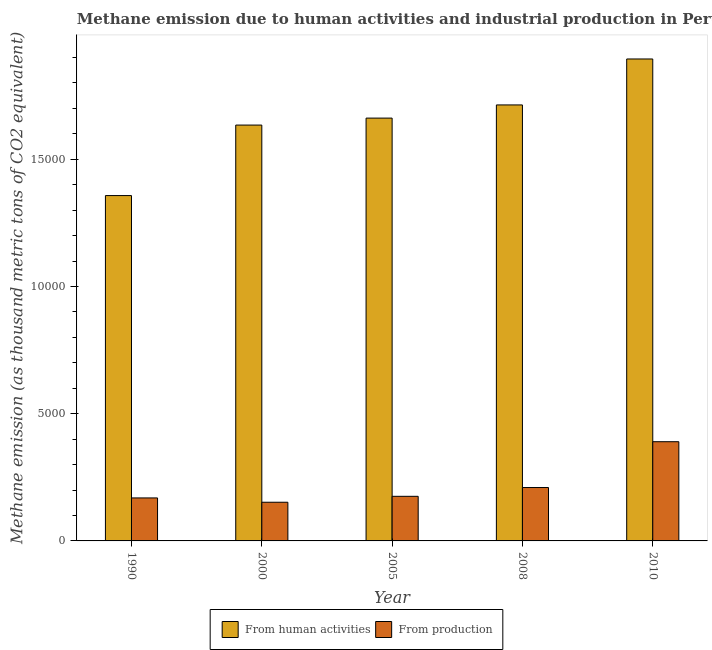How many different coloured bars are there?
Your answer should be compact. 2. How many groups of bars are there?
Offer a very short reply. 5. How many bars are there on the 2nd tick from the left?
Your response must be concise. 2. How many bars are there on the 3rd tick from the right?
Provide a short and direct response. 2. What is the label of the 1st group of bars from the left?
Offer a very short reply. 1990. In how many cases, is the number of bars for a given year not equal to the number of legend labels?
Your answer should be compact. 0. What is the amount of emissions from human activities in 2008?
Your answer should be very brief. 1.71e+04. Across all years, what is the maximum amount of emissions generated from industries?
Offer a terse response. 3899.3. Across all years, what is the minimum amount of emissions from human activities?
Your response must be concise. 1.36e+04. In which year was the amount of emissions from human activities maximum?
Offer a terse response. 2010. What is the total amount of emissions from human activities in the graph?
Ensure brevity in your answer.  8.26e+04. What is the difference between the amount of emissions generated from industries in 2000 and that in 2008?
Offer a terse response. -578.2. What is the difference between the amount of emissions generated from industries in 1990 and the amount of emissions from human activities in 2008?
Give a very brief answer. -408.9. What is the average amount of emissions from human activities per year?
Provide a short and direct response. 1.65e+04. In the year 1990, what is the difference between the amount of emissions from human activities and amount of emissions generated from industries?
Give a very brief answer. 0. In how many years, is the amount of emissions generated from industries greater than 14000 thousand metric tons?
Ensure brevity in your answer.  0. What is the ratio of the amount of emissions generated from industries in 1990 to that in 2005?
Offer a terse response. 0.96. What is the difference between the highest and the second highest amount of emissions generated from industries?
Offer a very short reply. 1800.6. What is the difference between the highest and the lowest amount of emissions from human activities?
Provide a short and direct response. 5369.2. In how many years, is the amount of emissions generated from industries greater than the average amount of emissions generated from industries taken over all years?
Your response must be concise. 1. What does the 2nd bar from the left in 2010 represents?
Provide a succinct answer. From production. What does the 2nd bar from the right in 2010 represents?
Provide a short and direct response. From human activities. How many years are there in the graph?
Your answer should be compact. 5. Where does the legend appear in the graph?
Give a very brief answer. Bottom center. What is the title of the graph?
Ensure brevity in your answer.  Methane emission due to human activities and industrial production in Peru. Does "Pregnant women" appear as one of the legend labels in the graph?
Your answer should be compact. No. What is the label or title of the X-axis?
Your answer should be very brief. Year. What is the label or title of the Y-axis?
Your response must be concise. Methane emission (as thousand metric tons of CO2 equivalent). What is the Methane emission (as thousand metric tons of CO2 equivalent) in From human activities in 1990?
Provide a short and direct response. 1.36e+04. What is the Methane emission (as thousand metric tons of CO2 equivalent) of From production in 1990?
Provide a succinct answer. 1689.8. What is the Methane emission (as thousand metric tons of CO2 equivalent) of From human activities in 2000?
Your response must be concise. 1.63e+04. What is the Methane emission (as thousand metric tons of CO2 equivalent) of From production in 2000?
Ensure brevity in your answer.  1520.5. What is the Methane emission (as thousand metric tons of CO2 equivalent) of From human activities in 2005?
Offer a very short reply. 1.66e+04. What is the Methane emission (as thousand metric tons of CO2 equivalent) of From production in 2005?
Your response must be concise. 1753.1. What is the Methane emission (as thousand metric tons of CO2 equivalent) in From human activities in 2008?
Offer a terse response. 1.71e+04. What is the Methane emission (as thousand metric tons of CO2 equivalent) in From production in 2008?
Ensure brevity in your answer.  2098.7. What is the Methane emission (as thousand metric tons of CO2 equivalent) of From human activities in 2010?
Provide a short and direct response. 1.89e+04. What is the Methane emission (as thousand metric tons of CO2 equivalent) in From production in 2010?
Your answer should be compact. 3899.3. Across all years, what is the maximum Methane emission (as thousand metric tons of CO2 equivalent) of From human activities?
Your response must be concise. 1.89e+04. Across all years, what is the maximum Methane emission (as thousand metric tons of CO2 equivalent) in From production?
Make the answer very short. 3899.3. Across all years, what is the minimum Methane emission (as thousand metric tons of CO2 equivalent) in From human activities?
Give a very brief answer. 1.36e+04. Across all years, what is the minimum Methane emission (as thousand metric tons of CO2 equivalent) in From production?
Give a very brief answer. 1520.5. What is the total Methane emission (as thousand metric tons of CO2 equivalent) in From human activities in the graph?
Offer a very short reply. 8.26e+04. What is the total Methane emission (as thousand metric tons of CO2 equivalent) of From production in the graph?
Your response must be concise. 1.10e+04. What is the difference between the Methane emission (as thousand metric tons of CO2 equivalent) of From human activities in 1990 and that in 2000?
Provide a short and direct response. -2771.4. What is the difference between the Methane emission (as thousand metric tons of CO2 equivalent) in From production in 1990 and that in 2000?
Provide a succinct answer. 169.3. What is the difference between the Methane emission (as thousand metric tons of CO2 equivalent) in From human activities in 1990 and that in 2005?
Offer a terse response. -3045.3. What is the difference between the Methane emission (as thousand metric tons of CO2 equivalent) of From production in 1990 and that in 2005?
Provide a short and direct response. -63.3. What is the difference between the Methane emission (as thousand metric tons of CO2 equivalent) of From human activities in 1990 and that in 2008?
Your answer should be very brief. -3562.7. What is the difference between the Methane emission (as thousand metric tons of CO2 equivalent) of From production in 1990 and that in 2008?
Ensure brevity in your answer.  -408.9. What is the difference between the Methane emission (as thousand metric tons of CO2 equivalent) in From human activities in 1990 and that in 2010?
Make the answer very short. -5369.2. What is the difference between the Methane emission (as thousand metric tons of CO2 equivalent) of From production in 1990 and that in 2010?
Give a very brief answer. -2209.5. What is the difference between the Methane emission (as thousand metric tons of CO2 equivalent) in From human activities in 2000 and that in 2005?
Offer a terse response. -273.9. What is the difference between the Methane emission (as thousand metric tons of CO2 equivalent) in From production in 2000 and that in 2005?
Provide a succinct answer. -232.6. What is the difference between the Methane emission (as thousand metric tons of CO2 equivalent) in From human activities in 2000 and that in 2008?
Keep it short and to the point. -791.3. What is the difference between the Methane emission (as thousand metric tons of CO2 equivalent) in From production in 2000 and that in 2008?
Keep it short and to the point. -578.2. What is the difference between the Methane emission (as thousand metric tons of CO2 equivalent) in From human activities in 2000 and that in 2010?
Ensure brevity in your answer.  -2597.8. What is the difference between the Methane emission (as thousand metric tons of CO2 equivalent) of From production in 2000 and that in 2010?
Offer a terse response. -2378.8. What is the difference between the Methane emission (as thousand metric tons of CO2 equivalent) in From human activities in 2005 and that in 2008?
Keep it short and to the point. -517.4. What is the difference between the Methane emission (as thousand metric tons of CO2 equivalent) of From production in 2005 and that in 2008?
Offer a terse response. -345.6. What is the difference between the Methane emission (as thousand metric tons of CO2 equivalent) of From human activities in 2005 and that in 2010?
Provide a succinct answer. -2323.9. What is the difference between the Methane emission (as thousand metric tons of CO2 equivalent) in From production in 2005 and that in 2010?
Make the answer very short. -2146.2. What is the difference between the Methane emission (as thousand metric tons of CO2 equivalent) in From human activities in 2008 and that in 2010?
Keep it short and to the point. -1806.5. What is the difference between the Methane emission (as thousand metric tons of CO2 equivalent) in From production in 2008 and that in 2010?
Give a very brief answer. -1800.6. What is the difference between the Methane emission (as thousand metric tons of CO2 equivalent) of From human activities in 1990 and the Methane emission (as thousand metric tons of CO2 equivalent) of From production in 2000?
Offer a terse response. 1.21e+04. What is the difference between the Methane emission (as thousand metric tons of CO2 equivalent) in From human activities in 1990 and the Methane emission (as thousand metric tons of CO2 equivalent) in From production in 2005?
Your response must be concise. 1.18e+04. What is the difference between the Methane emission (as thousand metric tons of CO2 equivalent) in From human activities in 1990 and the Methane emission (as thousand metric tons of CO2 equivalent) in From production in 2008?
Ensure brevity in your answer.  1.15e+04. What is the difference between the Methane emission (as thousand metric tons of CO2 equivalent) of From human activities in 1990 and the Methane emission (as thousand metric tons of CO2 equivalent) of From production in 2010?
Keep it short and to the point. 9674.4. What is the difference between the Methane emission (as thousand metric tons of CO2 equivalent) in From human activities in 2000 and the Methane emission (as thousand metric tons of CO2 equivalent) in From production in 2005?
Give a very brief answer. 1.46e+04. What is the difference between the Methane emission (as thousand metric tons of CO2 equivalent) of From human activities in 2000 and the Methane emission (as thousand metric tons of CO2 equivalent) of From production in 2008?
Your answer should be compact. 1.42e+04. What is the difference between the Methane emission (as thousand metric tons of CO2 equivalent) in From human activities in 2000 and the Methane emission (as thousand metric tons of CO2 equivalent) in From production in 2010?
Provide a short and direct response. 1.24e+04. What is the difference between the Methane emission (as thousand metric tons of CO2 equivalent) in From human activities in 2005 and the Methane emission (as thousand metric tons of CO2 equivalent) in From production in 2008?
Your answer should be very brief. 1.45e+04. What is the difference between the Methane emission (as thousand metric tons of CO2 equivalent) in From human activities in 2005 and the Methane emission (as thousand metric tons of CO2 equivalent) in From production in 2010?
Provide a succinct answer. 1.27e+04. What is the difference between the Methane emission (as thousand metric tons of CO2 equivalent) in From human activities in 2008 and the Methane emission (as thousand metric tons of CO2 equivalent) in From production in 2010?
Offer a very short reply. 1.32e+04. What is the average Methane emission (as thousand metric tons of CO2 equivalent) in From human activities per year?
Make the answer very short. 1.65e+04. What is the average Methane emission (as thousand metric tons of CO2 equivalent) in From production per year?
Provide a succinct answer. 2192.28. In the year 1990, what is the difference between the Methane emission (as thousand metric tons of CO2 equivalent) of From human activities and Methane emission (as thousand metric tons of CO2 equivalent) of From production?
Offer a very short reply. 1.19e+04. In the year 2000, what is the difference between the Methane emission (as thousand metric tons of CO2 equivalent) of From human activities and Methane emission (as thousand metric tons of CO2 equivalent) of From production?
Give a very brief answer. 1.48e+04. In the year 2005, what is the difference between the Methane emission (as thousand metric tons of CO2 equivalent) in From human activities and Methane emission (as thousand metric tons of CO2 equivalent) in From production?
Ensure brevity in your answer.  1.49e+04. In the year 2008, what is the difference between the Methane emission (as thousand metric tons of CO2 equivalent) in From human activities and Methane emission (as thousand metric tons of CO2 equivalent) in From production?
Your answer should be compact. 1.50e+04. In the year 2010, what is the difference between the Methane emission (as thousand metric tons of CO2 equivalent) in From human activities and Methane emission (as thousand metric tons of CO2 equivalent) in From production?
Make the answer very short. 1.50e+04. What is the ratio of the Methane emission (as thousand metric tons of CO2 equivalent) of From human activities in 1990 to that in 2000?
Your response must be concise. 0.83. What is the ratio of the Methane emission (as thousand metric tons of CO2 equivalent) in From production in 1990 to that in 2000?
Your answer should be compact. 1.11. What is the ratio of the Methane emission (as thousand metric tons of CO2 equivalent) in From human activities in 1990 to that in 2005?
Make the answer very short. 0.82. What is the ratio of the Methane emission (as thousand metric tons of CO2 equivalent) in From production in 1990 to that in 2005?
Your response must be concise. 0.96. What is the ratio of the Methane emission (as thousand metric tons of CO2 equivalent) in From human activities in 1990 to that in 2008?
Offer a terse response. 0.79. What is the ratio of the Methane emission (as thousand metric tons of CO2 equivalent) of From production in 1990 to that in 2008?
Offer a terse response. 0.81. What is the ratio of the Methane emission (as thousand metric tons of CO2 equivalent) of From human activities in 1990 to that in 2010?
Make the answer very short. 0.72. What is the ratio of the Methane emission (as thousand metric tons of CO2 equivalent) of From production in 1990 to that in 2010?
Keep it short and to the point. 0.43. What is the ratio of the Methane emission (as thousand metric tons of CO2 equivalent) of From human activities in 2000 to that in 2005?
Ensure brevity in your answer.  0.98. What is the ratio of the Methane emission (as thousand metric tons of CO2 equivalent) in From production in 2000 to that in 2005?
Your answer should be compact. 0.87. What is the ratio of the Methane emission (as thousand metric tons of CO2 equivalent) of From human activities in 2000 to that in 2008?
Your response must be concise. 0.95. What is the ratio of the Methane emission (as thousand metric tons of CO2 equivalent) of From production in 2000 to that in 2008?
Offer a very short reply. 0.72. What is the ratio of the Methane emission (as thousand metric tons of CO2 equivalent) of From human activities in 2000 to that in 2010?
Offer a very short reply. 0.86. What is the ratio of the Methane emission (as thousand metric tons of CO2 equivalent) of From production in 2000 to that in 2010?
Ensure brevity in your answer.  0.39. What is the ratio of the Methane emission (as thousand metric tons of CO2 equivalent) of From human activities in 2005 to that in 2008?
Provide a succinct answer. 0.97. What is the ratio of the Methane emission (as thousand metric tons of CO2 equivalent) of From production in 2005 to that in 2008?
Offer a very short reply. 0.84. What is the ratio of the Methane emission (as thousand metric tons of CO2 equivalent) in From human activities in 2005 to that in 2010?
Ensure brevity in your answer.  0.88. What is the ratio of the Methane emission (as thousand metric tons of CO2 equivalent) in From production in 2005 to that in 2010?
Ensure brevity in your answer.  0.45. What is the ratio of the Methane emission (as thousand metric tons of CO2 equivalent) of From human activities in 2008 to that in 2010?
Give a very brief answer. 0.9. What is the ratio of the Methane emission (as thousand metric tons of CO2 equivalent) in From production in 2008 to that in 2010?
Provide a succinct answer. 0.54. What is the difference between the highest and the second highest Methane emission (as thousand metric tons of CO2 equivalent) in From human activities?
Your response must be concise. 1806.5. What is the difference between the highest and the second highest Methane emission (as thousand metric tons of CO2 equivalent) of From production?
Provide a short and direct response. 1800.6. What is the difference between the highest and the lowest Methane emission (as thousand metric tons of CO2 equivalent) of From human activities?
Provide a succinct answer. 5369.2. What is the difference between the highest and the lowest Methane emission (as thousand metric tons of CO2 equivalent) of From production?
Your answer should be compact. 2378.8. 